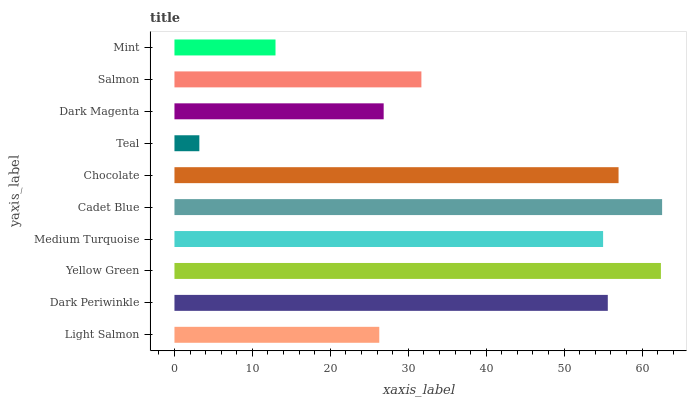Is Teal the minimum?
Answer yes or no. Yes. Is Cadet Blue the maximum?
Answer yes or no. Yes. Is Dark Periwinkle the minimum?
Answer yes or no. No. Is Dark Periwinkle the maximum?
Answer yes or no. No. Is Dark Periwinkle greater than Light Salmon?
Answer yes or no. Yes. Is Light Salmon less than Dark Periwinkle?
Answer yes or no. Yes. Is Light Salmon greater than Dark Periwinkle?
Answer yes or no. No. Is Dark Periwinkle less than Light Salmon?
Answer yes or no. No. Is Medium Turquoise the high median?
Answer yes or no. Yes. Is Salmon the low median?
Answer yes or no. Yes. Is Dark Periwinkle the high median?
Answer yes or no. No. Is Cadet Blue the low median?
Answer yes or no. No. 